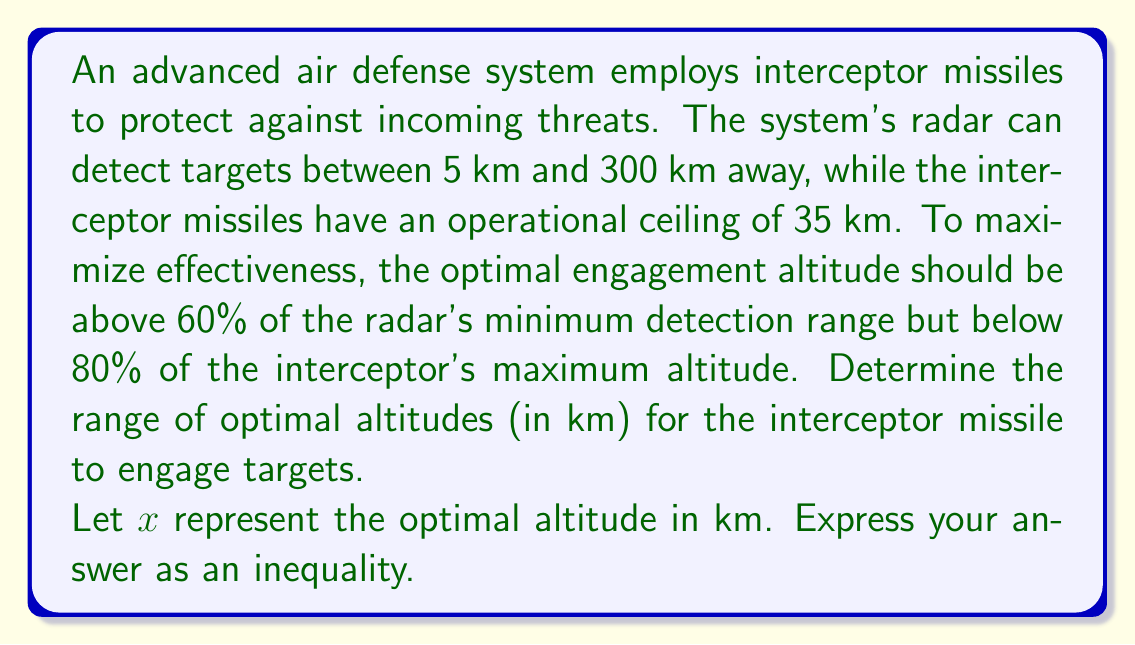Give your solution to this math problem. To solve this problem, we need to follow these steps:

1. Identify the given information:
   - Radar detection range: 5 km to 300 km
   - Interceptor missile operational ceiling: 35 km
   - Optimal engagement altitude: above 60% of radar's minimum detection range and below 80% of interceptor's maximum altitude

2. Calculate the lower bound of the optimal altitude range:
   - Minimum detection range = 5 km
   - Lower bound = 60% of 5 km
   - $0.60 \times 5 = 3$ km

3. Calculate the upper bound of the optimal altitude range:
   - Interceptor's maximum altitude = 35 km
   - Upper bound = 80% of 35 km
   - $0.80 \times 35 = 28$ km

4. Express the optimal altitude range as an inequality:
   - Let $x$ be the optimal altitude in km
   - The optimal altitude should be greater than 3 km and less than 28 km
   - This can be written as: $3 < x < 28$

Therefore, the optimal altitude range for the interceptor missile to engage targets can be expressed as the inequality $3 < x < 28$, where $x$ is the altitude in kilometers.
Answer: $3 < x < 28$, where $x$ is the altitude in km 